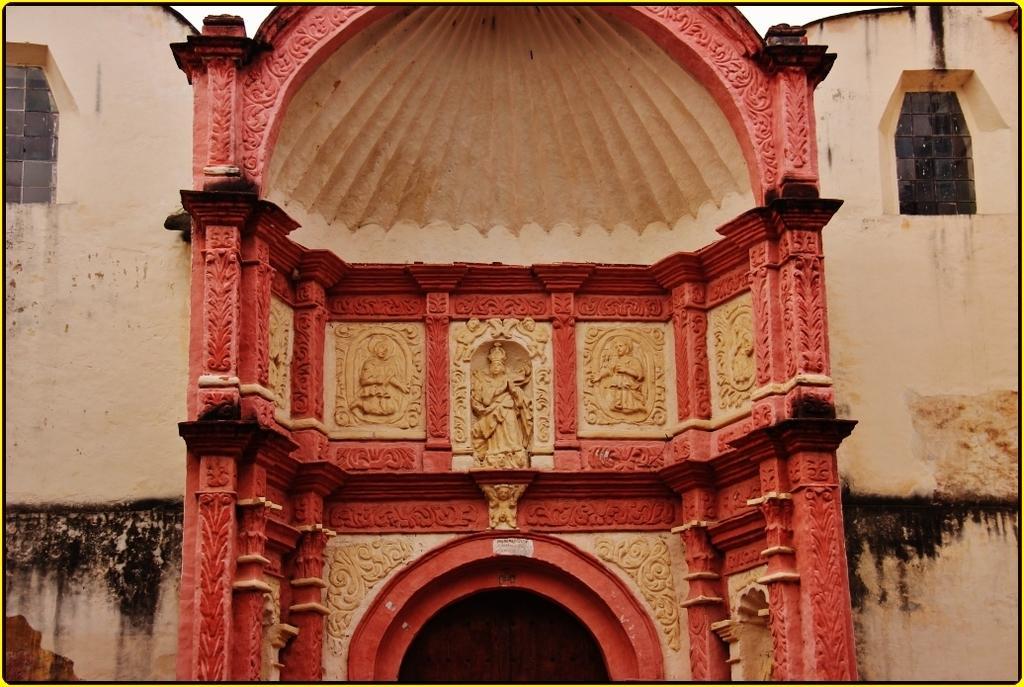Describe this image in one or two sentences. In this image I can see the building which is cream, pink and black in color. I can see few sculptures on the entrance of the building and I can see two windows of the building which are black in color. In the background I can see the sky. 